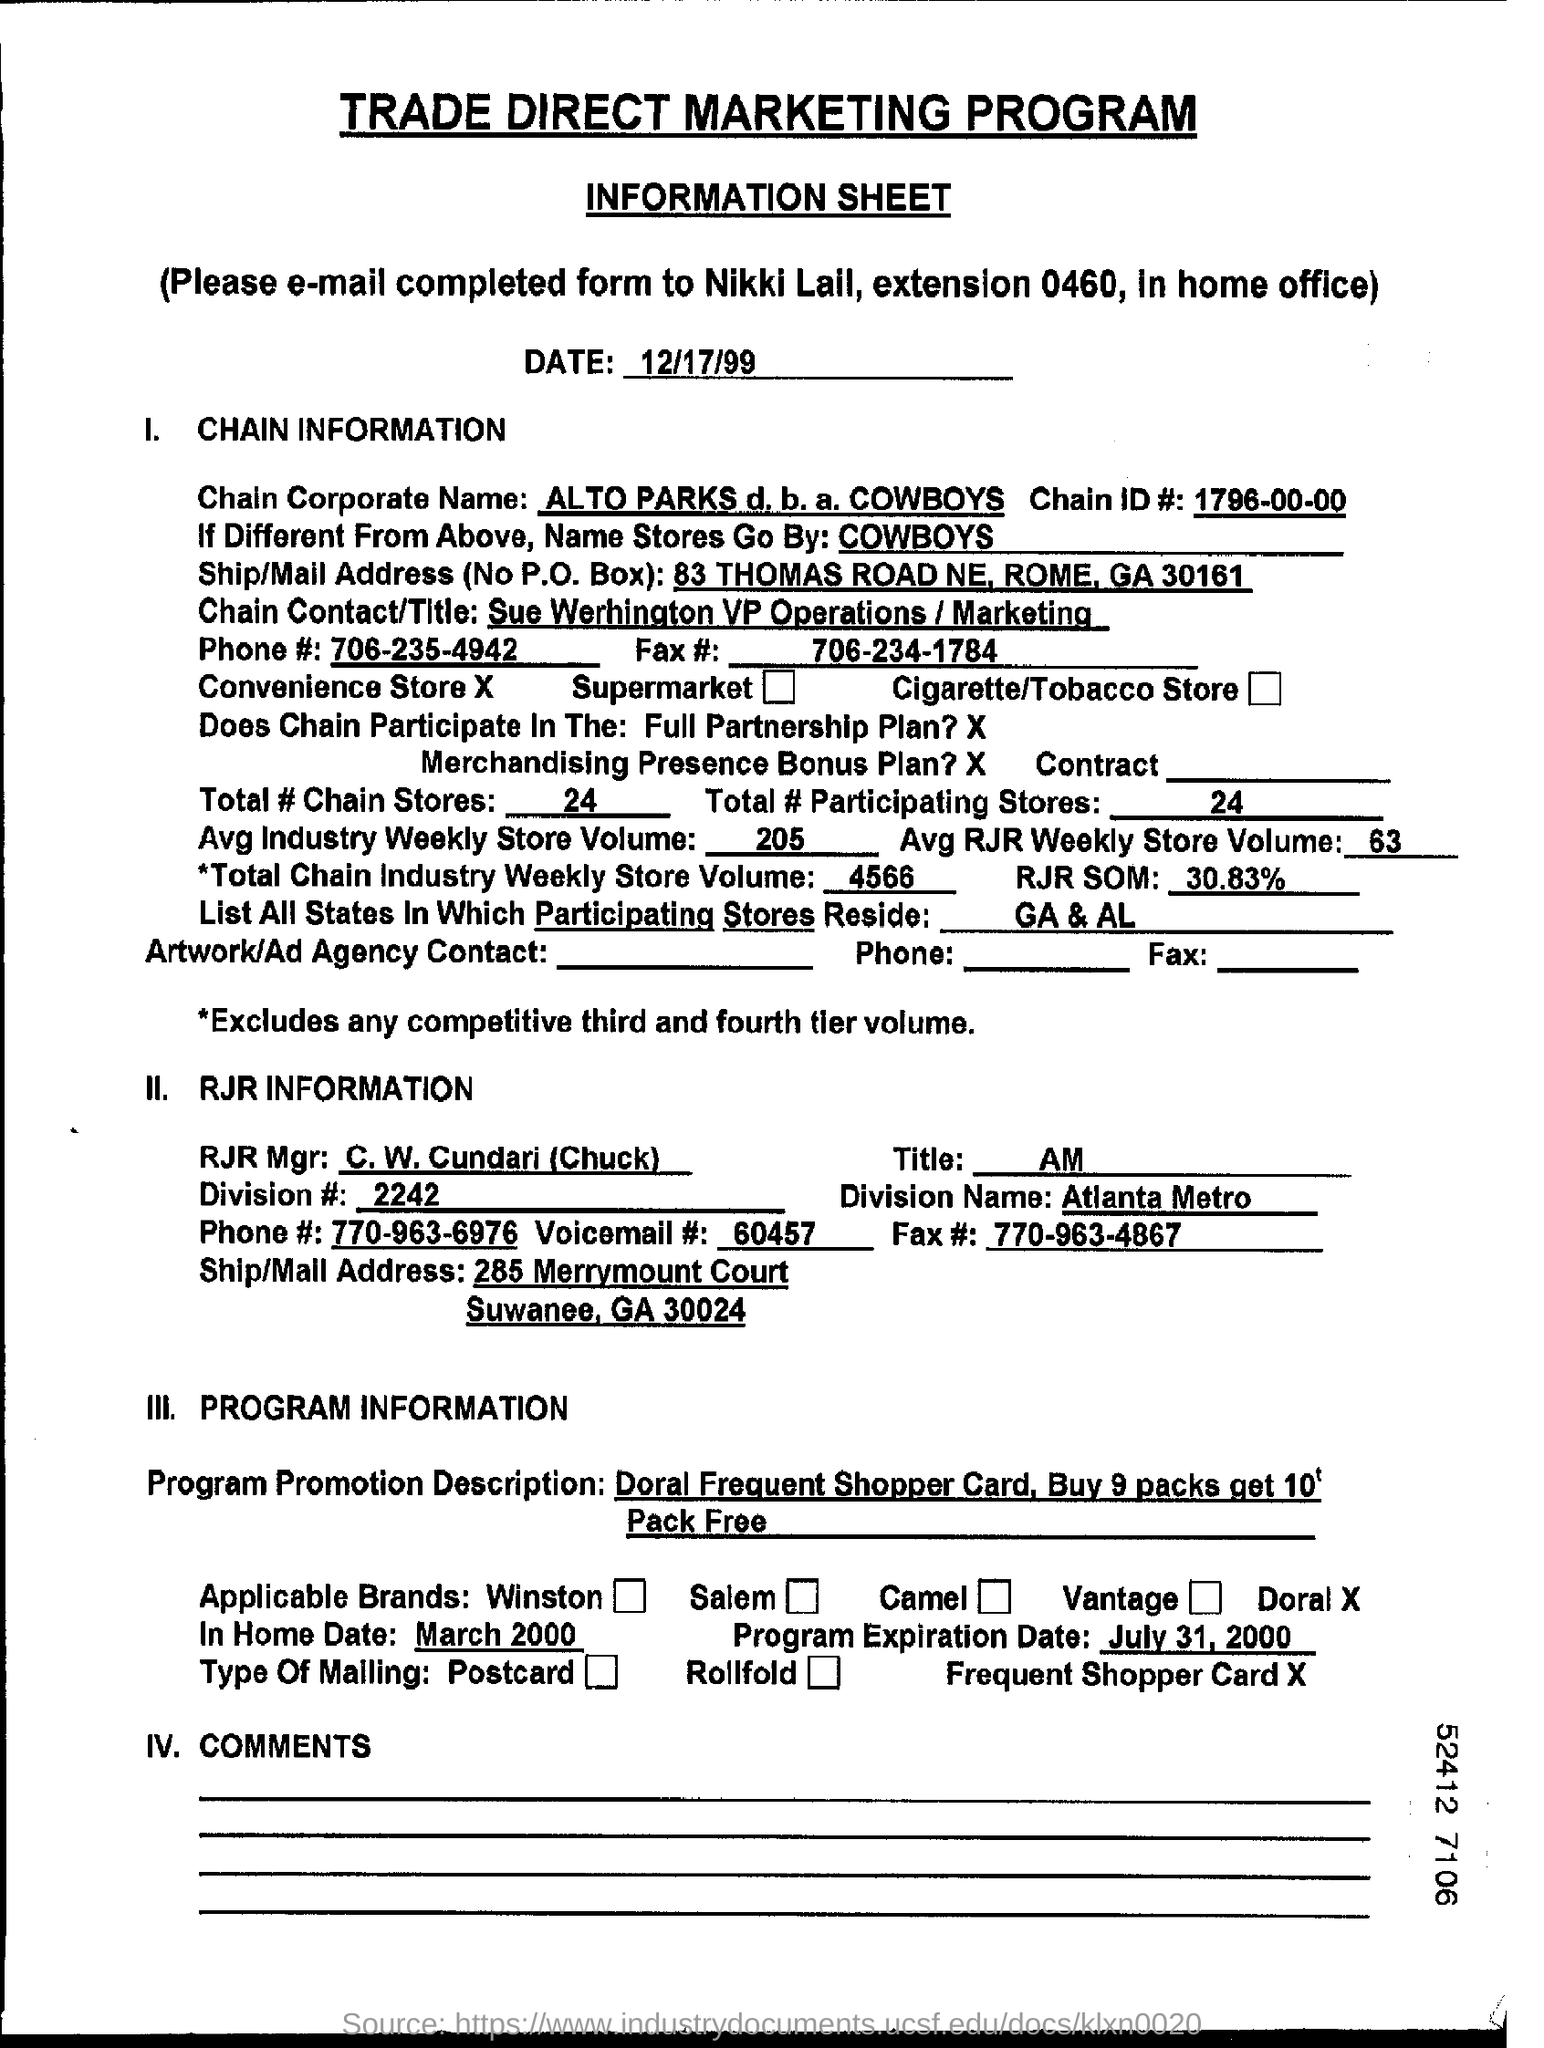What is the date on the document?
Keep it short and to the point. 12/17/99. What is the Chain ID #?
Your answer should be compact. 1796-00-00. What is the Phone #?
Give a very brief answer. 706-235-4942. What is the Fax #?
Provide a succinct answer. 706-234-1784. What is the Total # of Chain Stores?
Give a very brief answer. 24. What is the Total # of Participating Stores?
Your response must be concise. 24. What is the Voicemail #?
Your response must be concise. 60457. What is the Program Expiration Date?
Offer a terse response. July 31 , 2000. 